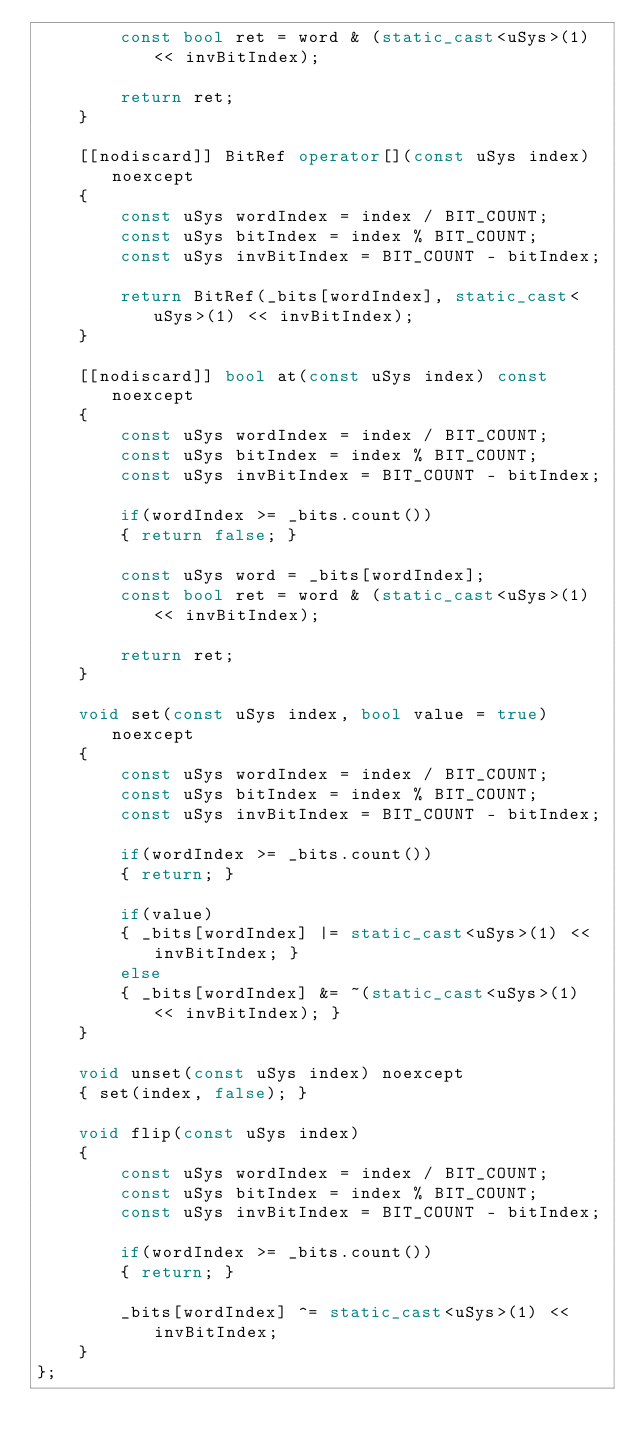Convert code to text. <code><loc_0><loc_0><loc_500><loc_500><_C++_>        const bool ret = word & (static_cast<uSys>(1) << invBitIndex);

        return ret;
    }

    [[nodiscard]] BitRef operator[](const uSys index) noexcept
    {
        const uSys wordIndex = index / BIT_COUNT;
        const uSys bitIndex = index % BIT_COUNT;
        const uSys invBitIndex = BIT_COUNT - bitIndex;

        return BitRef(_bits[wordIndex], static_cast<uSys>(1) << invBitIndex);
    }

    [[nodiscard]] bool at(const uSys index) const noexcept
    {
        const uSys wordIndex = index / BIT_COUNT;
        const uSys bitIndex = index % BIT_COUNT;
        const uSys invBitIndex = BIT_COUNT - bitIndex;

        if(wordIndex >= _bits.count())
        { return false; }

        const uSys word = _bits[wordIndex];
        const bool ret = word & (static_cast<uSys>(1) << invBitIndex);

        return ret;
    }

    void set(const uSys index, bool value = true) noexcept
    {
        const uSys wordIndex = index / BIT_COUNT;
        const uSys bitIndex = index % BIT_COUNT;
        const uSys invBitIndex = BIT_COUNT - bitIndex;
        
        if(wordIndex >= _bits.count())
        { return; }
        
        if(value)
        { _bits[wordIndex] |= static_cast<uSys>(1) << invBitIndex; }
        else
        { _bits[wordIndex] &= ~(static_cast<uSys>(1) << invBitIndex); }
    }

    void unset(const uSys index) noexcept
    { set(index, false); }

    void flip(const uSys index)
    {
        const uSys wordIndex = index / BIT_COUNT;
        const uSys bitIndex = index % BIT_COUNT;
        const uSys invBitIndex = BIT_COUNT - bitIndex;
        
        if(wordIndex >= _bits.count())
        { return; }
        
        _bits[wordIndex] ^= static_cast<uSys>(1) << invBitIndex;
    }
};
</code> 